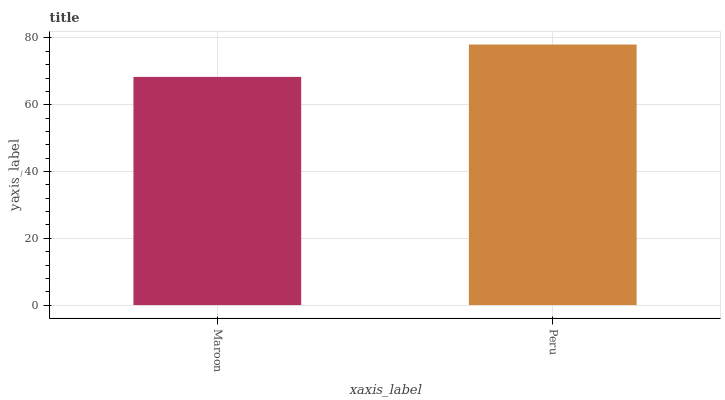Is Maroon the minimum?
Answer yes or no. Yes. Is Peru the maximum?
Answer yes or no. Yes. Is Peru the minimum?
Answer yes or no. No. Is Peru greater than Maroon?
Answer yes or no. Yes. Is Maroon less than Peru?
Answer yes or no. Yes. Is Maroon greater than Peru?
Answer yes or no. No. Is Peru less than Maroon?
Answer yes or no. No. Is Peru the high median?
Answer yes or no. Yes. Is Maroon the low median?
Answer yes or no. Yes. Is Maroon the high median?
Answer yes or no. No. Is Peru the low median?
Answer yes or no. No. 